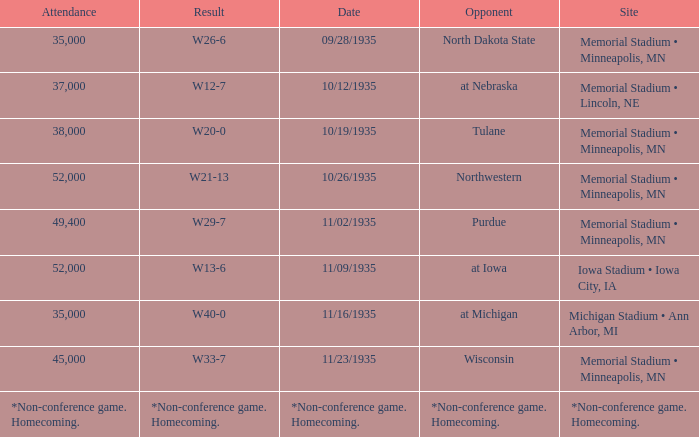How many spectators attended the game on 11/09/1935? 52000.0. 